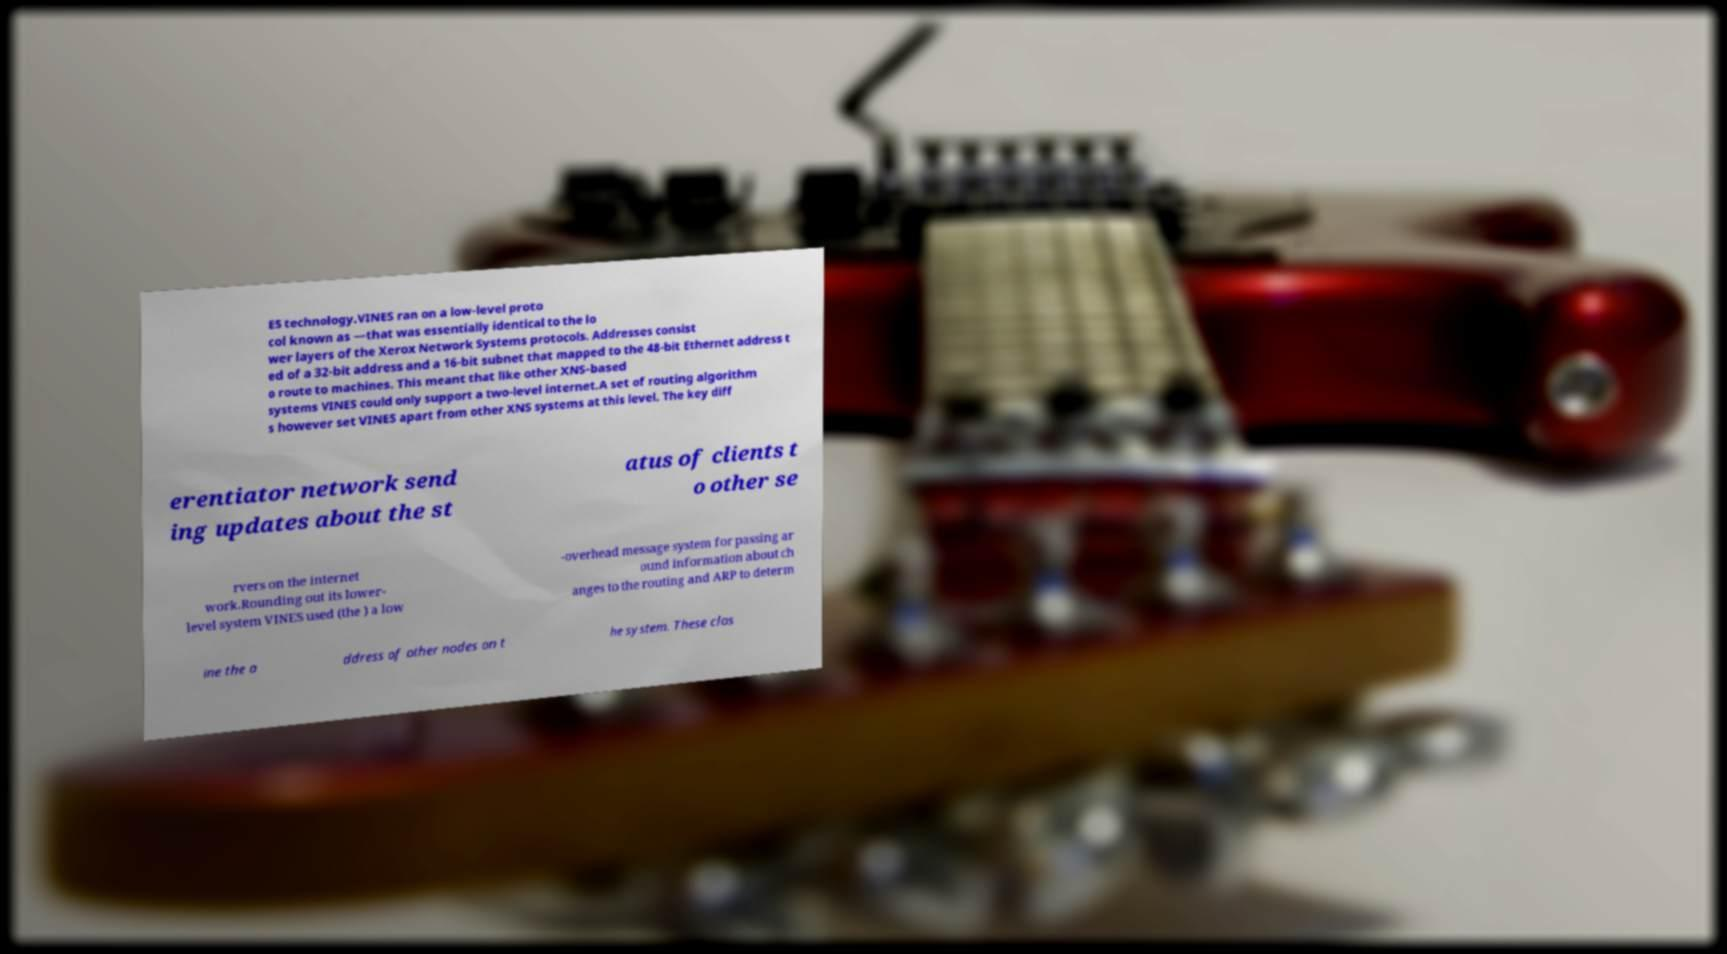Can you accurately transcribe the text from the provided image for me? ES technology.VINES ran on a low-level proto col known as —that was essentially identical to the lo wer layers of the Xerox Network Systems protocols. Addresses consist ed of a 32-bit address and a 16-bit subnet that mapped to the 48-bit Ethernet address t o route to machines. This meant that like other XNS-based systems VINES could only support a two-level internet.A set of routing algorithm s however set VINES apart from other XNS systems at this level. The key diff erentiator network send ing updates about the st atus of clients t o other se rvers on the internet work.Rounding out its lower- level system VINES used (the ) a low -overhead message system for passing ar ound information about ch anges to the routing and ARP to determ ine the a ddress of other nodes on t he system. These clos 